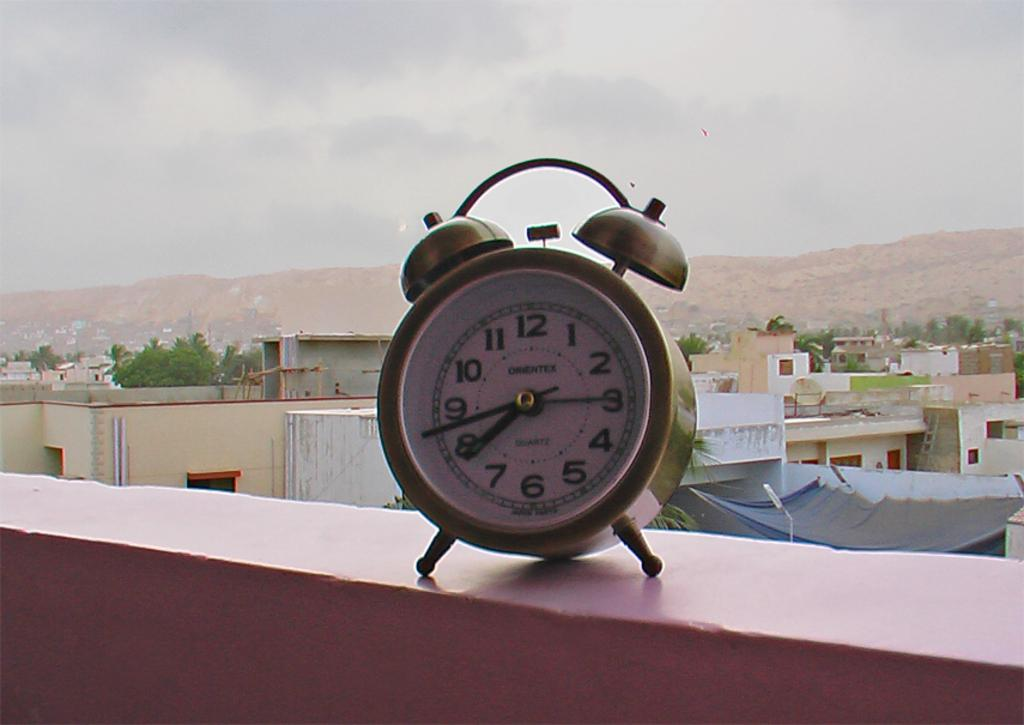<image>
Describe the image concisely. A clock with the hands showing the time of 7:43 